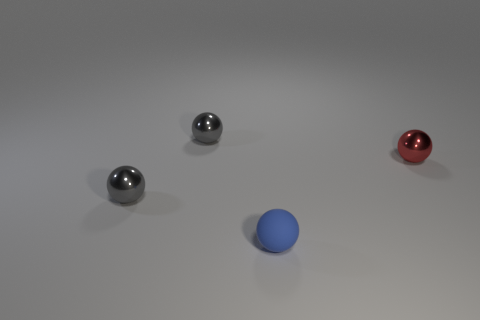Subtract all red balls. How many balls are left? 3 Subtract all tiny matte balls. How many balls are left? 3 Subtract all purple balls. Subtract all yellow cylinders. How many balls are left? 4 Add 1 small blue matte balls. How many objects exist? 5 Add 4 blue rubber things. How many blue rubber things are left? 5 Add 1 balls. How many balls exist? 5 Subtract 0 blue cylinders. How many objects are left? 4 Subtract all red balls. Subtract all gray balls. How many objects are left? 1 